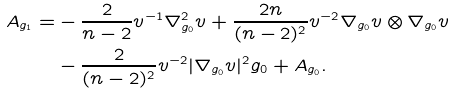Convert formula to latex. <formula><loc_0><loc_0><loc_500><loc_500>A _ { g _ { 1 } } = & - \frac { 2 } { n - 2 } v ^ { - 1 } \nabla _ { g _ { 0 } } ^ { 2 } v + \frac { 2 n } { ( n - 2 ) ^ { 2 } } v ^ { - 2 } \nabla _ { g _ { 0 } } v \otimes \nabla _ { g _ { 0 } } v \\ & - \frac { 2 } { ( n - 2 ) ^ { 2 } } v ^ { - 2 } | \nabla _ { g _ { 0 } } v | ^ { 2 } g _ { 0 } + A _ { g _ { 0 } } .</formula> 